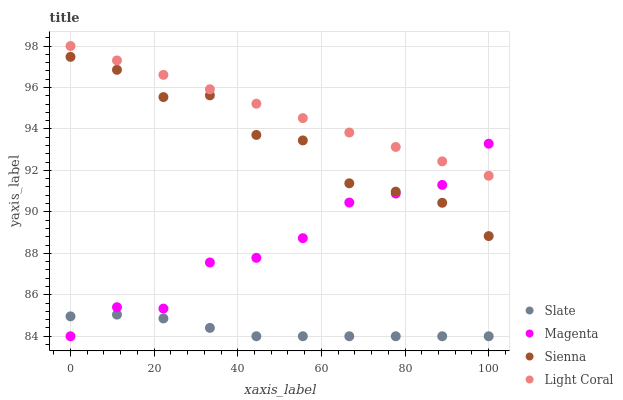Does Slate have the minimum area under the curve?
Answer yes or no. Yes. Does Light Coral have the maximum area under the curve?
Answer yes or no. Yes. Does Light Coral have the minimum area under the curve?
Answer yes or no. No. Does Slate have the maximum area under the curve?
Answer yes or no. No. Is Light Coral the smoothest?
Answer yes or no. Yes. Is Sienna the roughest?
Answer yes or no. Yes. Is Slate the smoothest?
Answer yes or no. No. Is Slate the roughest?
Answer yes or no. No. Does Slate have the lowest value?
Answer yes or no. Yes. Does Light Coral have the lowest value?
Answer yes or no. No. Does Light Coral have the highest value?
Answer yes or no. Yes. Does Slate have the highest value?
Answer yes or no. No. Is Slate less than Light Coral?
Answer yes or no. Yes. Is Light Coral greater than Slate?
Answer yes or no. Yes. Does Magenta intersect Slate?
Answer yes or no. Yes. Is Magenta less than Slate?
Answer yes or no. No. Is Magenta greater than Slate?
Answer yes or no. No. Does Slate intersect Light Coral?
Answer yes or no. No. 